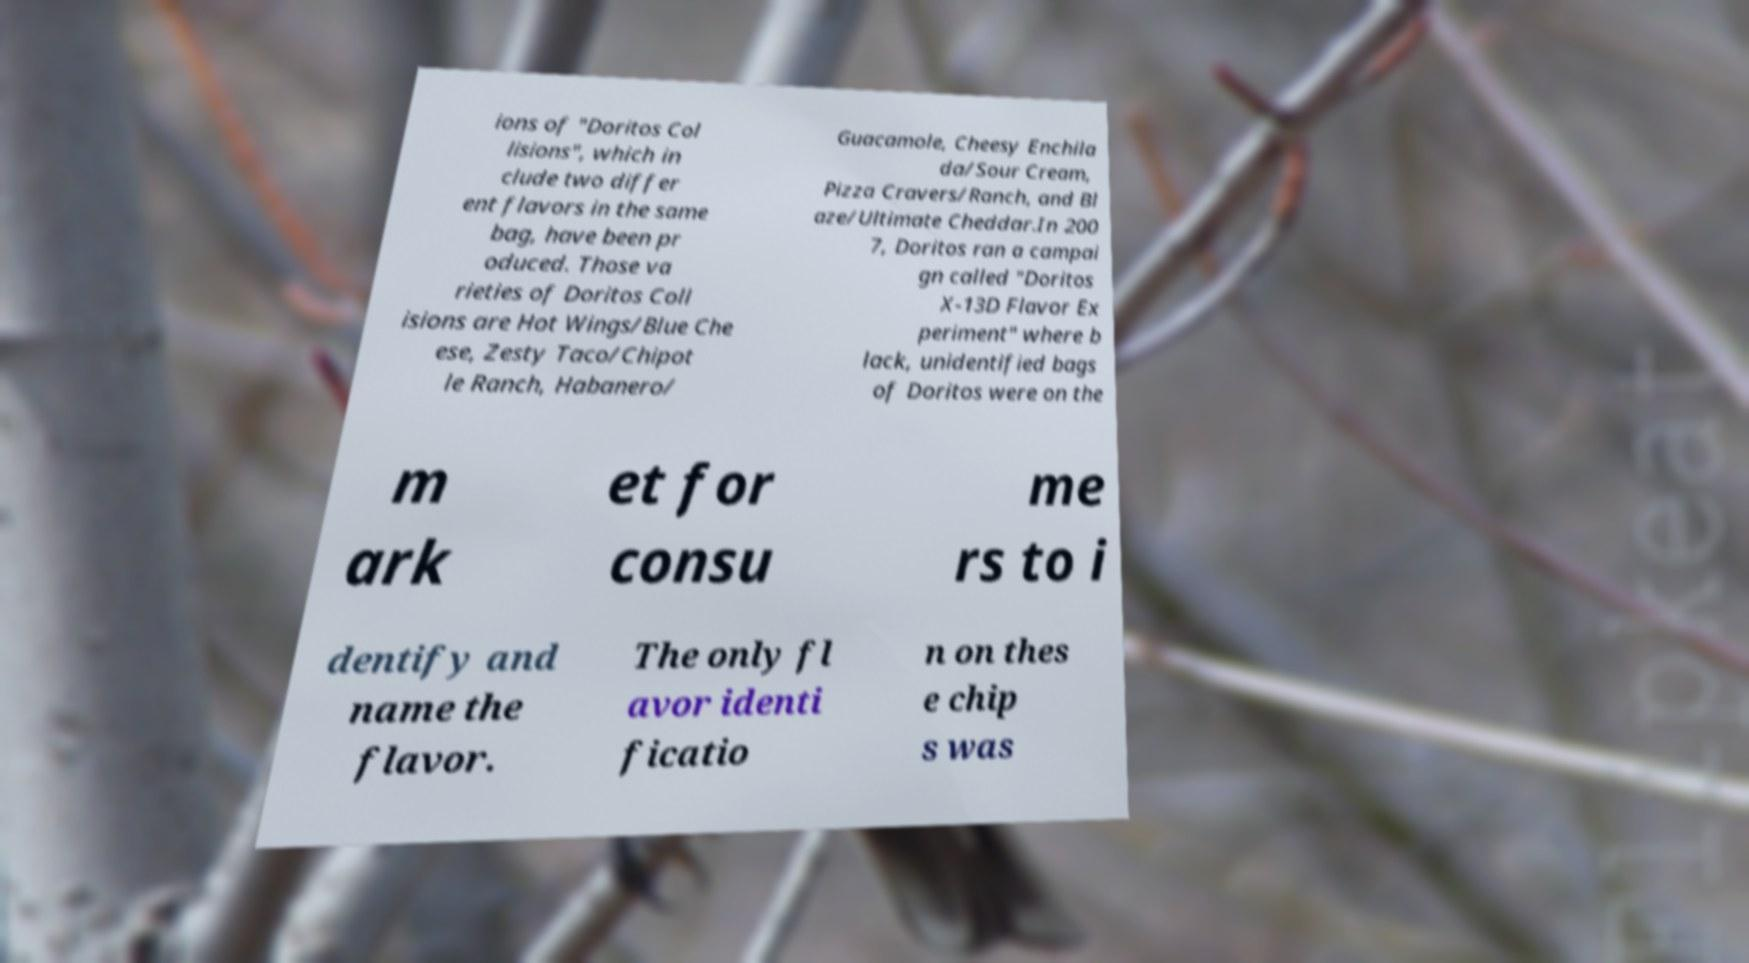Could you assist in decoding the text presented in this image and type it out clearly? ions of "Doritos Col lisions", which in clude two differ ent flavors in the same bag, have been pr oduced. Those va rieties of Doritos Coll isions are Hot Wings/Blue Che ese, Zesty Taco/Chipot le Ranch, Habanero/ Guacamole, Cheesy Enchila da/Sour Cream, Pizza Cravers/Ranch, and Bl aze/Ultimate Cheddar.In 200 7, Doritos ran a campai gn called "Doritos X-13D Flavor Ex periment" where b lack, unidentified bags of Doritos were on the m ark et for consu me rs to i dentify and name the flavor. The only fl avor identi ficatio n on thes e chip s was 